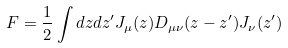Convert formula to latex. <formula><loc_0><loc_0><loc_500><loc_500>F = \frac { 1 } { 2 } \int d z d z ^ { \prime } J _ { \mu } ( z ) D _ { \mu \nu } ( z - z ^ { \prime } ) J _ { \nu } ( z ^ { \prime } )</formula> 